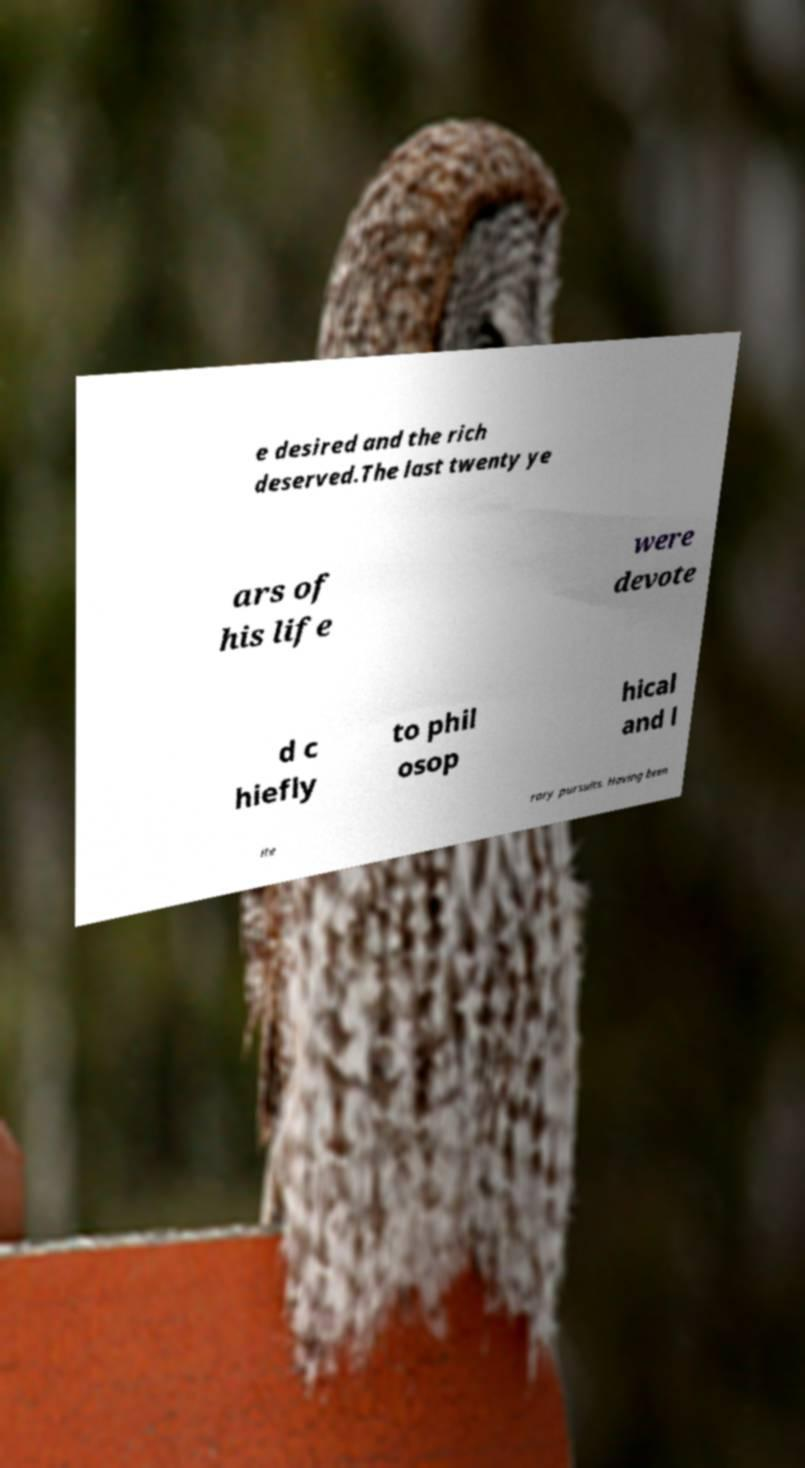There's text embedded in this image that I need extracted. Can you transcribe it verbatim? e desired and the rich deserved.The last twenty ye ars of his life were devote d c hiefly to phil osop hical and l ite rary pursuits. Having been 